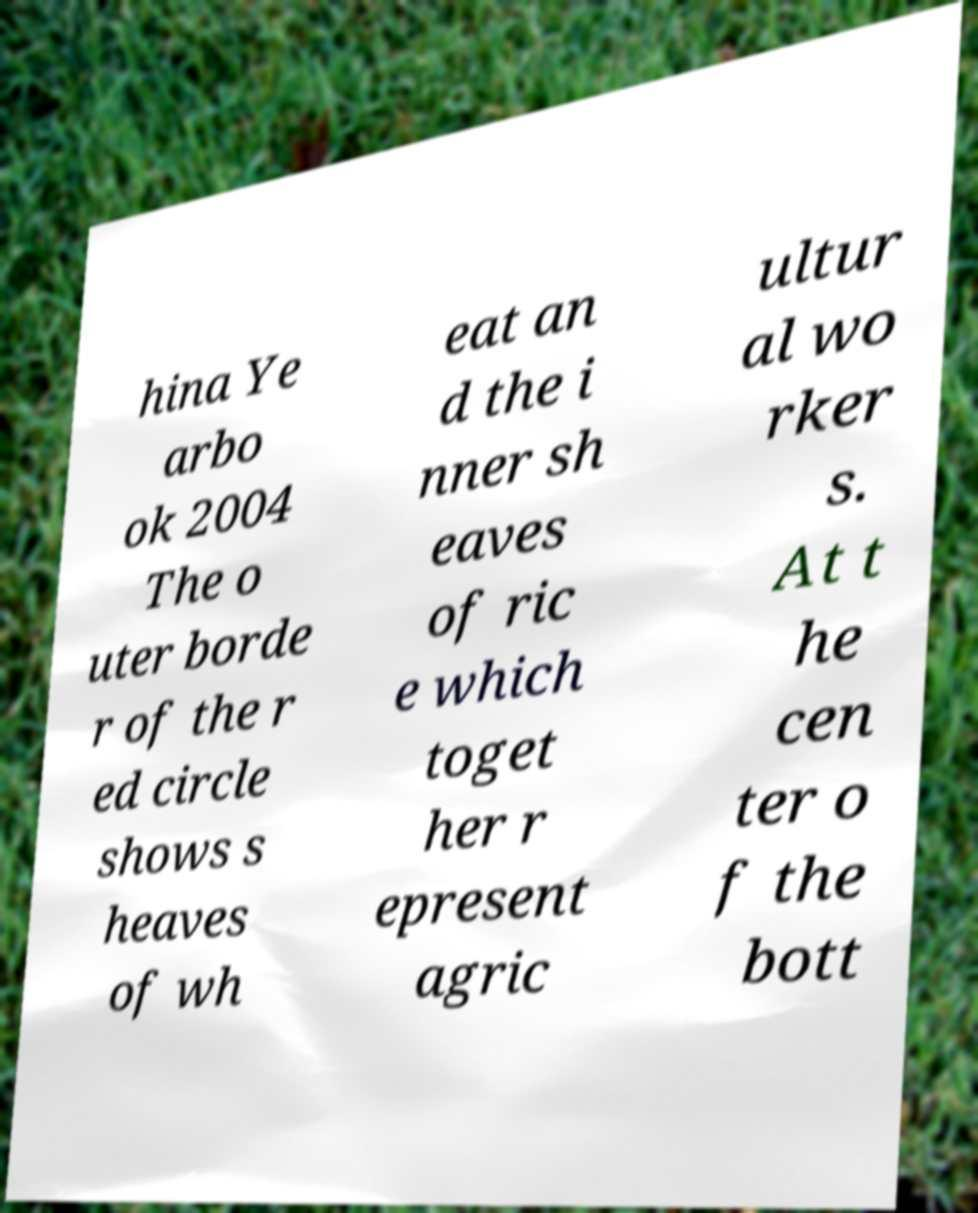I need the written content from this picture converted into text. Can you do that? hina Ye arbo ok 2004 The o uter borde r of the r ed circle shows s heaves of wh eat an d the i nner sh eaves of ric e which toget her r epresent agric ultur al wo rker s. At t he cen ter o f the bott 